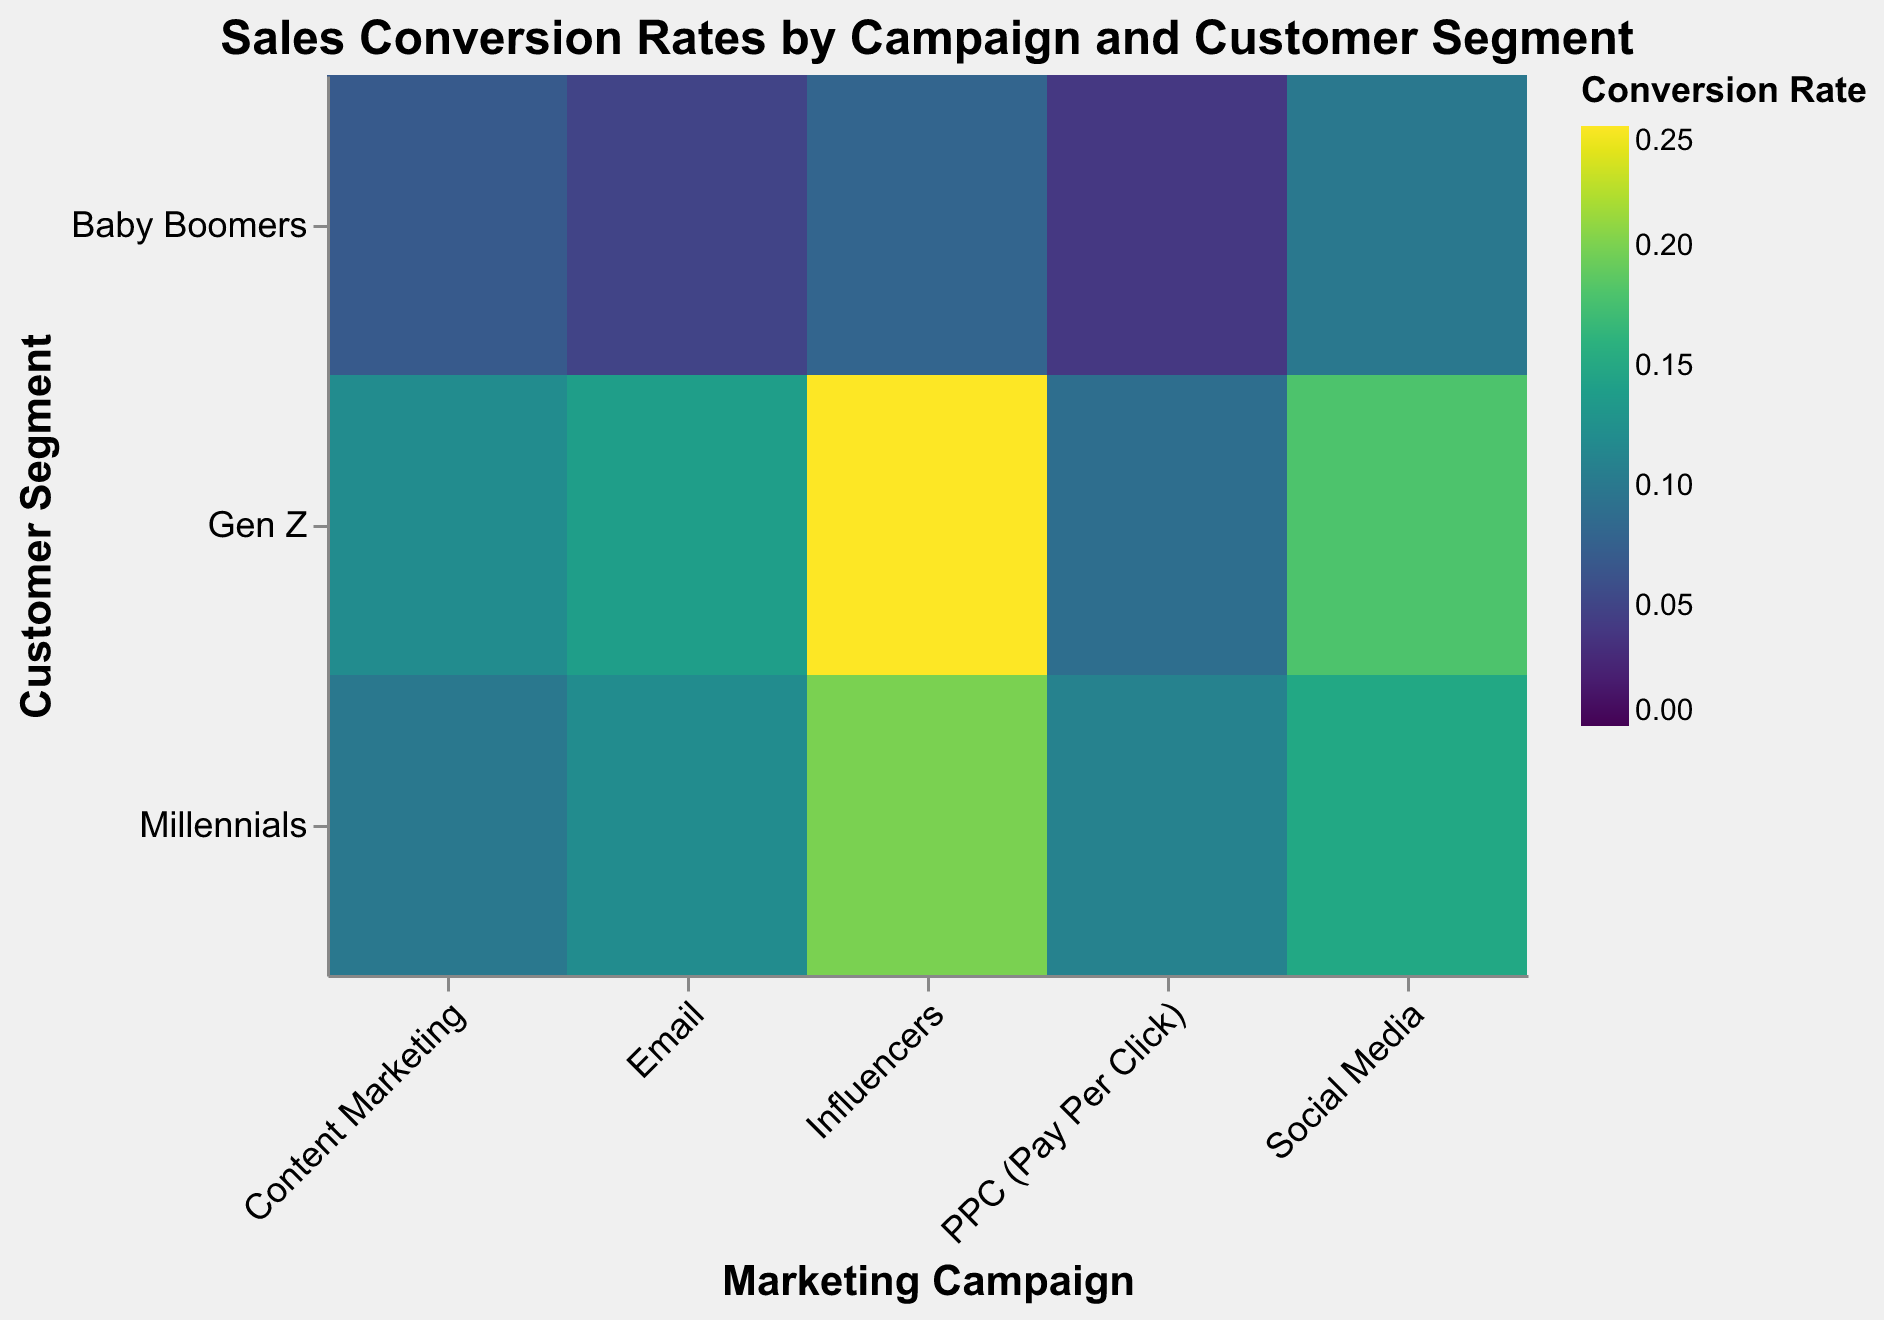what is the title of the heatmap? The title is located at the top of the heatmap and it is usually the largest text. It reads: "Sales Conversion Rates by Campaign and Customer Segment".
Answer: Sales Conversion Rates by Campaign and Customer Segment Which marketing campaign has the highest conversion rate for Gen Z? By scanning the color scale for Gen Z and comparing the corresponding cells, the Influencers campaign has the darkest color. The tooltip confirms a conversion rate of 0.25 for Influencers and Gen Z.
Answer: Influencers Which customer segment has the lowest conversion rate in the Email campaign? By examining the colors in the Email campaign column and referring to the conversion rates, Baby Boomers have the lowest rate. The tooltip will show 0.05 for Email and Baby Boomers.
Answer: Baby Boomers How does the conversion rate for Millennials in Social Media compare to that of Gen Z in the same campaign? Checking the two cells under Social Media, Millennials have a conversion rate of 0.15, whereas Gen Z has 0.18. Since 0.15 is less than 0.18, Millennials have a lower conversion rate.
Answer: Lower What is the average conversion rate for the PPC (Pay Per Click) campaign across all customer segments? The conversion rates for PPC (Pay Per Click) campaign are 0.11 (Millennials), 0.09 (Gen Z), and 0.04 (Baby Boomers). The average is calculated as (0.11 + 0.09 + 0.04) / 3 = 0.08.
Answer: 0.08 Which customer segment shows the highest variability in conversion rates across different campaigns? By comparing the range of conversion rates for each customer segment across all campaigns: Millennials (0.10 to 0.20), Gen Z (0.09 to 0.25), and Baby Boomers (0.04 to 0.10). Gen Z has the widest range from 0.09 to 0.25.
Answer: Gen Z What color scheme is used to represent the conversion rates in the heatmap? The color scheme is indicated by the legend which shows a gradient from light to dark colors based on the conversion rate. The color scheme used is 'viridis'.
Answer: viridis Which campaign has the overall lowest conversion rate, regardless of customer segment? Looking for the lightest-colored cells within each campaign, PPC (Pay Per Click) has the lowest with 0.09 for Gen Z and 0.04 for Baby Boomers.
Answer: PPC (Pay Per Click) What is the range of conversion rates for the Influencers campaign? The conversion rates for Influencers are 0.20 (Millennials), 0.25 (Gen Z), and 0.08 (Baby Boomers). The range is 0.25 - 0.08 = 0.17.
Answer: 0.17 Can we identify which customer segment prefers Social Media campaign the most based on conversion rates? By checking the conversion rates for Social Media, Gen Z has the highest conversion rate at 0.18, which is higher compared to Millennials at 0.15 and Baby Boomers at 0.10.
Answer: Gen Z 